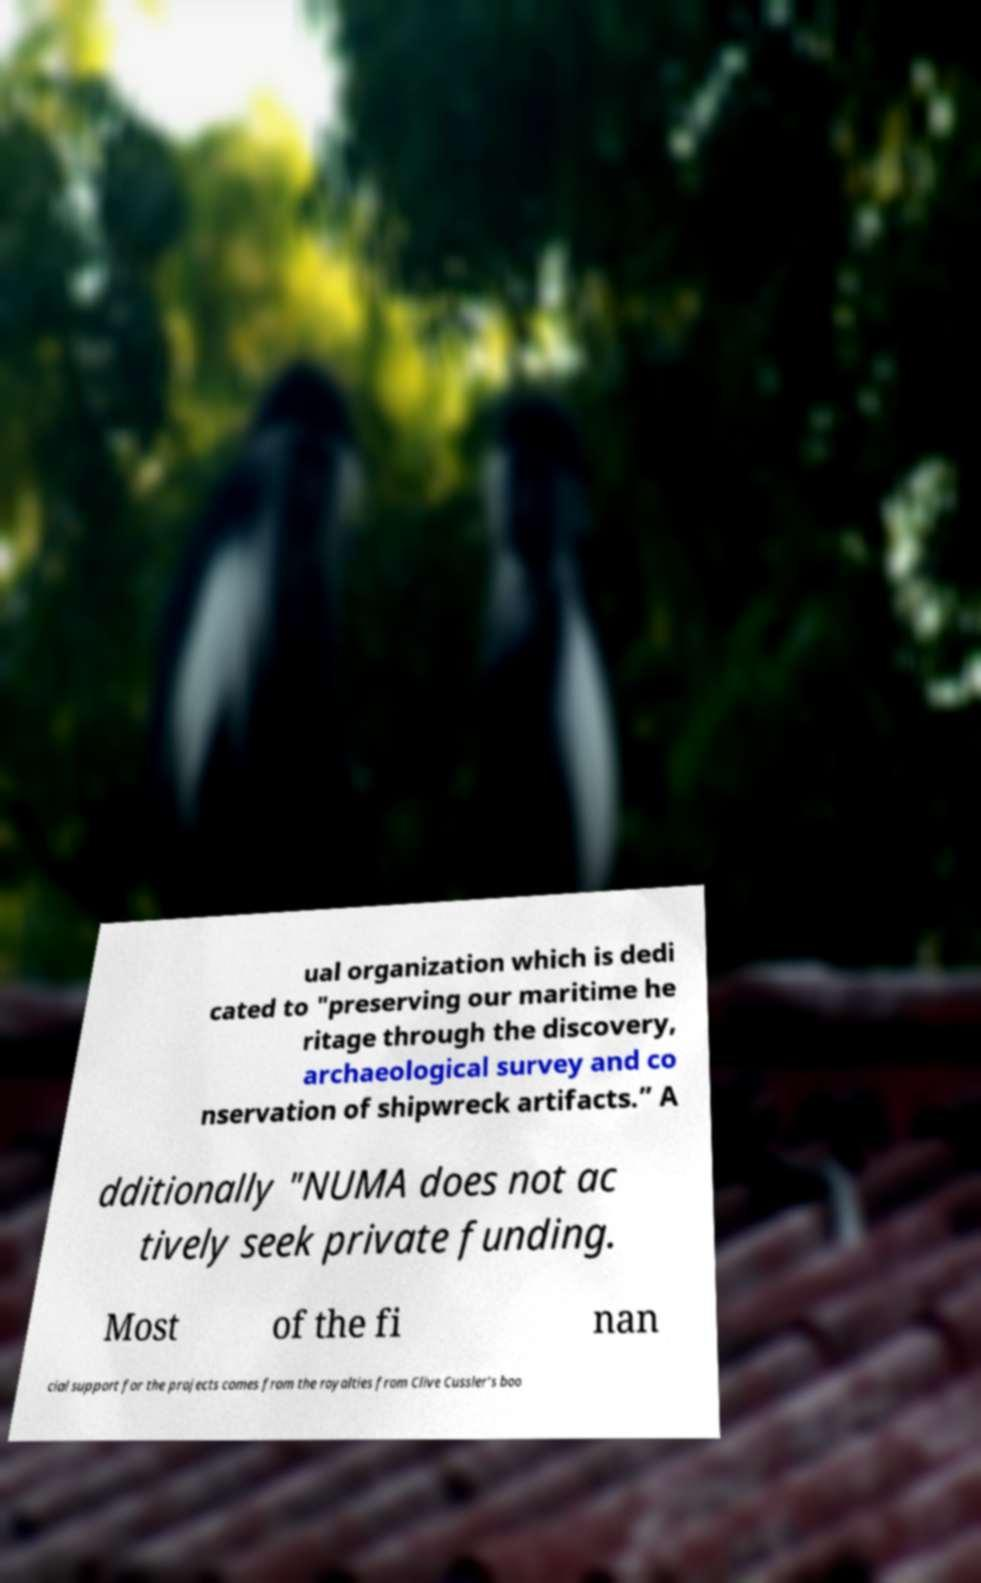Please identify and transcribe the text found in this image. ual organization which is dedi cated to "preserving our maritime he ritage through the discovery, archaeological survey and co nservation of shipwreck artifacts.” A dditionally "NUMA does not ac tively seek private funding. Most of the fi nan cial support for the projects comes from the royalties from Clive Cussler’s boo 